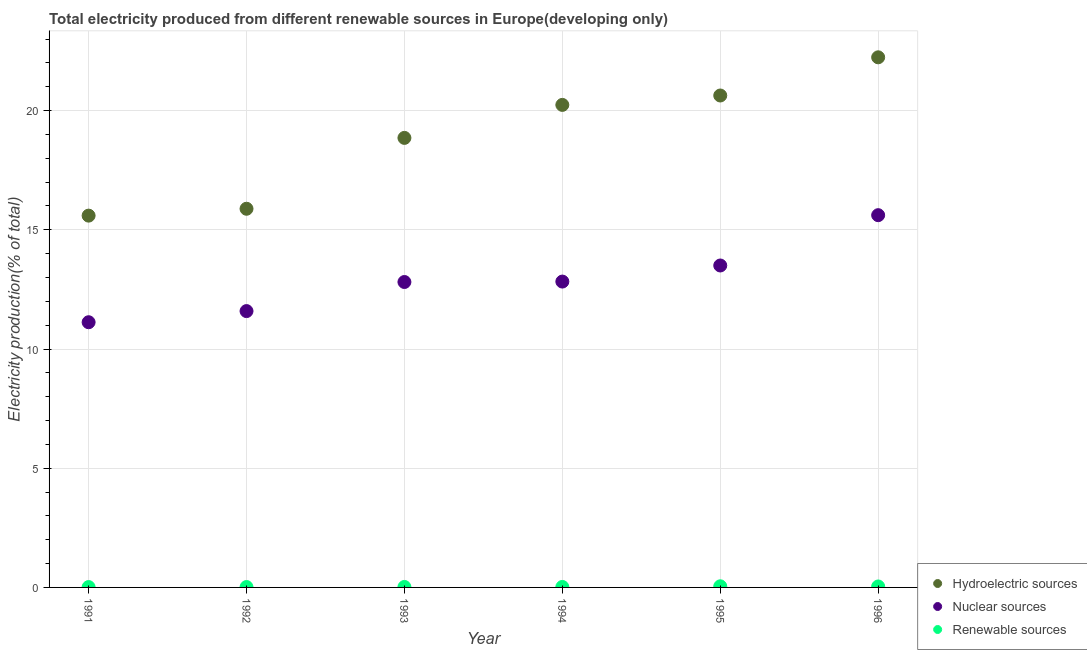How many different coloured dotlines are there?
Give a very brief answer. 3. What is the percentage of electricity produced by renewable sources in 1993?
Provide a succinct answer. 0.02. Across all years, what is the maximum percentage of electricity produced by renewable sources?
Make the answer very short. 0.05. Across all years, what is the minimum percentage of electricity produced by renewable sources?
Keep it short and to the point. 0.01. In which year was the percentage of electricity produced by renewable sources maximum?
Offer a terse response. 1995. In which year was the percentage of electricity produced by hydroelectric sources minimum?
Make the answer very short. 1991. What is the total percentage of electricity produced by renewable sources in the graph?
Offer a terse response. 0.16. What is the difference between the percentage of electricity produced by renewable sources in 1993 and that in 1994?
Make the answer very short. -0. What is the difference between the percentage of electricity produced by nuclear sources in 1995 and the percentage of electricity produced by hydroelectric sources in 1992?
Provide a short and direct response. -2.38. What is the average percentage of electricity produced by hydroelectric sources per year?
Ensure brevity in your answer.  18.91. In the year 1992, what is the difference between the percentage of electricity produced by nuclear sources and percentage of electricity produced by renewable sources?
Provide a succinct answer. 11.58. In how many years, is the percentage of electricity produced by hydroelectric sources greater than 1 %?
Ensure brevity in your answer.  6. What is the ratio of the percentage of electricity produced by renewable sources in 1991 to that in 1995?
Keep it short and to the point. 0.32. What is the difference between the highest and the second highest percentage of electricity produced by renewable sources?
Keep it short and to the point. 0.01. What is the difference between the highest and the lowest percentage of electricity produced by hydroelectric sources?
Provide a short and direct response. 6.64. In how many years, is the percentage of electricity produced by renewable sources greater than the average percentage of electricity produced by renewable sources taken over all years?
Provide a succinct answer. 2. Does the percentage of electricity produced by nuclear sources monotonically increase over the years?
Offer a very short reply. Yes. Does the graph contain any zero values?
Your answer should be compact. No. How are the legend labels stacked?
Offer a terse response. Vertical. What is the title of the graph?
Offer a terse response. Total electricity produced from different renewable sources in Europe(developing only). Does "Social Protection and Labor" appear as one of the legend labels in the graph?
Your answer should be very brief. No. What is the Electricity production(% of total) of Hydroelectric sources in 1991?
Offer a very short reply. 15.6. What is the Electricity production(% of total) of Nuclear sources in 1991?
Provide a succinct answer. 11.12. What is the Electricity production(% of total) in Renewable sources in 1991?
Ensure brevity in your answer.  0.01. What is the Electricity production(% of total) of Hydroelectric sources in 1992?
Give a very brief answer. 15.88. What is the Electricity production(% of total) of Nuclear sources in 1992?
Give a very brief answer. 11.59. What is the Electricity production(% of total) in Renewable sources in 1992?
Your response must be concise. 0.02. What is the Electricity production(% of total) of Hydroelectric sources in 1993?
Provide a succinct answer. 18.86. What is the Electricity production(% of total) in Nuclear sources in 1993?
Keep it short and to the point. 12.81. What is the Electricity production(% of total) of Renewable sources in 1993?
Give a very brief answer. 0.02. What is the Electricity production(% of total) in Hydroelectric sources in 1994?
Provide a short and direct response. 20.24. What is the Electricity production(% of total) of Nuclear sources in 1994?
Make the answer very short. 12.83. What is the Electricity production(% of total) of Renewable sources in 1994?
Your response must be concise. 0.02. What is the Electricity production(% of total) in Hydroelectric sources in 1995?
Provide a short and direct response. 20.63. What is the Electricity production(% of total) in Nuclear sources in 1995?
Give a very brief answer. 13.5. What is the Electricity production(% of total) in Renewable sources in 1995?
Ensure brevity in your answer.  0.05. What is the Electricity production(% of total) in Hydroelectric sources in 1996?
Give a very brief answer. 22.24. What is the Electricity production(% of total) in Nuclear sources in 1996?
Give a very brief answer. 15.61. What is the Electricity production(% of total) of Renewable sources in 1996?
Offer a terse response. 0.04. Across all years, what is the maximum Electricity production(% of total) of Hydroelectric sources?
Provide a succinct answer. 22.24. Across all years, what is the maximum Electricity production(% of total) of Nuclear sources?
Offer a terse response. 15.61. Across all years, what is the maximum Electricity production(% of total) in Renewable sources?
Give a very brief answer. 0.05. Across all years, what is the minimum Electricity production(% of total) in Hydroelectric sources?
Provide a succinct answer. 15.6. Across all years, what is the minimum Electricity production(% of total) in Nuclear sources?
Give a very brief answer. 11.12. Across all years, what is the minimum Electricity production(% of total) in Renewable sources?
Provide a succinct answer. 0.01. What is the total Electricity production(% of total) of Hydroelectric sources in the graph?
Give a very brief answer. 113.45. What is the total Electricity production(% of total) of Nuclear sources in the graph?
Provide a succinct answer. 77.48. What is the total Electricity production(% of total) in Renewable sources in the graph?
Keep it short and to the point. 0.16. What is the difference between the Electricity production(% of total) in Hydroelectric sources in 1991 and that in 1992?
Your response must be concise. -0.29. What is the difference between the Electricity production(% of total) of Nuclear sources in 1991 and that in 1992?
Your answer should be very brief. -0.47. What is the difference between the Electricity production(% of total) of Renewable sources in 1991 and that in 1992?
Your answer should be very brief. -0. What is the difference between the Electricity production(% of total) of Hydroelectric sources in 1991 and that in 1993?
Your response must be concise. -3.26. What is the difference between the Electricity production(% of total) in Nuclear sources in 1991 and that in 1993?
Give a very brief answer. -1.69. What is the difference between the Electricity production(% of total) in Renewable sources in 1991 and that in 1993?
Your answer should be compact. -0. What is the difference between the Electricity production(% of total) in Hydroelectric sources in 1991 and that in 1994?
Your answer should be compact. -4.64. What is the difference between the Electricity production(% of total) in Nuclear sources in 1991 and that in 1994?
Your answer should be very brief. -1.71. What is the difference between the Electricity production(% of total) in Renewable sources in 1991 and that in 1994?
Provide a succinct answer. -0. What is the difference between the Electricity production(% of total) in Hydroelectric sources in 1991 and that in 1995?
Provide a short and direct response. -5.04. What is the difference between the Electricity production(% of total) of Nuclear sources in 1991 and that in 1995?
Keep it short and to the point. -2.38. What is the difference between the Electricity production(% of total) in Renewable sources in 1991 and that in 1995?
Offer a very short reply. -0.03. What is the difference between the Electricity production(% of total) of Hydroelectric sources in 1991 and that in 1996?
Your response must be concise. -6.64. What is the difference between the Electricity production(% of total) of Nuclear sources in 1991 and that in 1996?
Offer a terse response. -4.49. What is the difference between the Electricity production(% of total) in Renewable sources in 1991 and that in 1996?
Offer a very short reply. -0.03. What is the difference between the Electricity production(% of total) in Hydroelectric sources in 1992 and that in 1993?
Offer a terse response. -2.97. What is the difference between the Electricity production(% of total) of Nuclear sources in 1992 and that in 1993?
Make the answer very short. -1.22. What is the difference between the Electricity production(% of total) of Renewable sources in 1992 and that in 1993?
Offer a very short reply. -0. What is the difference between the Electricity production(% of total) of Hydroelectric sources in 1992 and that in 1994?
Ensure brevity in your answer.  -4.36. What is the difference between the Electricity production(% of total) of Nuclear sources in 1992 and that in 1994?
Keep it short and to the point. -1.24. What is the difference between the Electricity production(% of total) of Renewable sources in 1992 and that in 1994?
Make the answer very short. -0. What is the difference between the Electricity production(% of total) in Hydroelectric sources in 1992 and that in 1995?
Your answer should be very brief. -4.75. What is the difference between the Electricity production(% of total) in Nuclear sources in 1992 and that in 1995?
Provide a short and direct response. -1.91. What is the difference between the Electricity production(% of total) of Renewable sources in 1992 and that in 1995?
Your answer should be very brief. -0.03. What is the difference between the Electricity production(% of total) of Hydroelectric sources in 1992 and that in 1996?
Provide a succinct answer. -6.35. What is the difference between the Electricity production(% of total) in Nuclear sources in 1992 and that in 1996?
Ensure brevity in your answer.  -4.02. What is the difference between the Electricity production(% of total) in Renewable sources in 1992 and that in 1996?
Your response must be concise. -0.02. What is the difference between the Electricity production(% of total) of Hydroelectric sources in 1993 and that in 1994?
Give a very brief answer. -1.38. What is the difference between the Electricity production(% of total) of Nuclear sources in 1993 and that in 1994?
Provide a succinct answer. -0.02. What is the difference between the Electricity production(% of total) in Renewable sources in 1993 and that in 1994?
Offer a terse response. -0. What is the difference between the Electricity production(% of total) in Hydroelectric sources in 1993 and that in 1995?
Ensure brevity in your answer.  -1.78. What is the difference between the Electricity production(% of total) of Nuclear sources in 1993 and that in 1995?
Offer a terse response. -0.69. What is the difference between the Electricity production(% of total) in Renewable sources in 1993 and that in 1995?
Your answer should be compact. -0.03. What is the difference between the Electricity production(% of total) in Hydroelectric sources in 1993 and that in 1996?
Keep it short and to the point. -3.38. What is the difference between the Electricity production(% of total) in Nuclear sources in 1993 and that in 1996?
Provide a succinct answer. -2.8. What is the difference between the Electricity production(% of total) in Renewable sources in 1993 and that in 1996?
Your answer should be compact. -0.02. What is the difference between the Electricity production(% of total) of Hydroelectric sources in 1994 and that in 1995?
Offer a very short reply. -0.39. What is the difference between the Electricity production(% of total) in Nuclear sources in 1994 and that in 1995?
Ensure brevity in your answer.  -0.67. What is the difference between the Electricity production(% of total) in Renewable sources in 1994 and that in 1995?
Give a very brief answer. -0.03. What is the difference between the Electricity production(% of total) in Hydroelectric sources in 1994 and that in 1996?
Your answer should be compact. -2. What is the difference between the Electricity production(% of total) in Nuclear sources in 1994 and that in 1996?
Provide a succinct answer. -2.79. What is the difference between the Electricity production(% of total) in Renewable sources in 1994 and that in 1996?
Ensure brevity in your answer.  -0.02. What is the difference between the Electricity production(% of total) in Hydroelectric sources in 1995 and that in 1996?
Your answer should be compact. -1.6. What is the difference between the Electricity production(% of total) in Nuclear sources in 1995 and that in 1996?
Your answer should be very brief. -2.11. What is the difference between the Electricity production(% of total) of Renewable sources in 1995 and that in 1996?
Offer a very short reply. 0.01. What is the difference between the Electricity production(% of total) of Hydroelectric sources in 1991 and the Electricity production(% of total) of Nuclear sources in 1992?
Offer a terse response. 4. What is the difference between the Electricity production(% of total) in Hydroelectric sources in 1991 and the Electricity production(% of total) in Renewable sources in 1992?
Your response must be concise. 15.58. What is the difference between the Electricity production(% of total) in Nuclear sources in 1991 and the Electricity production(% of total) in Renewable sources in 1992?
Ensure brevity in your answer.  11.11. What is the difference between the Electricity production(% of total) of Hydroelectric sources in 1991 and the Electricity production(% of total) of Nuclear sources in 1993?
Your response must be concise. 2.78. What is the difference between the Electricity production(% of total) of Hydroelectric sources in 1991 and the Electricity production(% of total) of Renewable sources in 1993?
Keep it short and to the point. 15.58. What is the difference between the Electricity production(% of total) in Nuclear sources in 1991 and the Electricity production(% of total) in Renewable sources in 1993?
Give a very brief answer. 11.1. What is the difference between the Electricity production(% of total) of Hydroelectric sources in 1991 and the Electricity production(% of total) of Nuclear sources in 1994?
Provide a succinct answer. 2.77. What is the difference between the Electricity production(% of total) in Hydroelectric sources in 1991 and the Electricity production(% of total) in Renewable sources in 1994?
Your answer should be compact. 15.58. What is the difference between the Electricity production(% of total) of Nuclear sources in 1991 and the Electricity production(% of total) of Renewable sources in 1994?
Your answer should be compact. 11.1. What is the difference between the Electricity production(% of total) of Hydroelectric sources in 1991 and the Electricity production(% of total) of Nuclear sources in 1995?
Your answer should be compact. 2.09. What is the difference between the Electricity production(% of total) of Hydroelectric sources in 1991 and the Electricity production(% of total) of Renewable sources in 1995?
Your response must be concise. 15.55. What is the difference between the Electricity production(% of total) in Nuclear sources in 1991 and the Electricity production(% of total) in Renewable sources in 1995?
Offer a terse response. 11.08. What is the difference between the Electricity production(% of total) in Hydroelectric sources in 1991 and the Electricity production(% of total) in Nuclear sources in 1996?
Your answer should be very brief. -0.02. What is the difference between the Electricity production(% of total) in Hydroelectric sources in 1991 and the Electricity production(% of total) in Renewable sources in 1996?
Your response must be concise. 15.56. What is the difference between the Electricity production(% of total) in Nuclear sources in 1991 and the Electricity production(% of total) in Renewable sources in 1996?
Give a very brief answer. 11.08. What is the difference between the Electricity production(% of total) in Hydroelectric sources in 1992 and the Electricity production(% of total) in Nuclear sources in 1993?
Provide a succinct answer. 3.07. What is the difference between the Electricity production(% of total) in Hydroelectric sources in 1992 and the Electricity production(% of total) in Renewable sources in 1993?
Your answer should be very brief. 15.86. What is the difference between the Electricity production(% of total) of Nuclear sources in 1992 and the Electricity production(% of total) of Renewable sources in 1993?
Ensure brevity in your answer.  11.57. What is the difference between the Electricity production(% of total) in Hydroelectric sources in 1992 and the Electricity production(% of total) in Nuclear sources in 1994?
Offer a very short reply. 3.05. What is the difference between the Electricity production(% of total) in Hydroelectric sources in 1992 and the Electricity production(% of total) in Renewable sources in 1994?
Provide a short and direct response. 15.86. What is the difference between the Electricity production(% of total) of Nuclear sources in 1992 and the Electricity production(% of total) of Renewable sources in 1994?
Make the answer very short. 11.57. What is the difference between the Electricity production(% of total) in Hydroelectric sources in 1992 and the Electricity production(% of total) in Nuclear sources in 1995?
Your answer should be very brief. 2.38. What is the difference between the Electricity production(% of total) of Hydroelectric sources in 1992 and the Electricity production(% of total) of Renewable sources in 1995?
Make the answer very short. 15.84. What is the difference between the Electricity production(% of total) of Nuclear sources in 1992 and the Electricity production(% of total) of Renewable sources in 1995?
Provide a succinct answer. 11.54. What is the difference between the Electricity production(% of total) in Hydroelectric sources in 1992 and the Electricity production(% of total) in Nuclear sources in 1996?
Give a very brief answer. 0.27. What is the difference between the Electricity production(% of total) in Hydroelectric sources in 1992 and the Electricity production(% of total) in Renewable sources in 1996?
Make the answer very short. 15.84. What is the difference between the Electricity production(% of total) in Nuclear sources in 1992 and the Electricity production(% of total) in Renewable sources in 1996?
Your answer should be very brief. 11.55. What is the difference between the Electricity production(% of total) of Hydroelectric sources in 1993 and the Electricity production(% of total) of Nuclear sources in 1994?
Offer a very short reply. 6.03. What is the difference between the Electricity production(% of total) of Hydroelectric sources in 1993 and the Electricity production(% of total) of Renewable sources in 1994?
Offer a very short reply. 18.84. What is the difference between the Electricity production(% of total) in Nuclear sources in 1993 and the Electricity production(% of total) in Renewable sources in 1994?
Your answer should be compact. 12.79. What is the difference between the Electricity production(% of total) of Hydroelectric sources in 1993 and the Electricity production(% of total) of Nuclear sources in 1995?
Your answer should be compact. 5.35. What is the difference between the Electricity production(% of total) of Hydroelectric sources in 1993 and the Electricity production(% of total) of Renewable sources in 1995?
Provide a succinct answer. 18.81. What is the difference between the Electricity production(% of total) of Nuclear sources in 1993 and the Electricity production(% of total) of Renewable sources in 1995?
Offer a very short reply. 12.76. What is the difference between the Electricity production(% of total) of Hydroelectric sources in 1993 and the Electricity production(% of total) of Nuclear sources in 1996?
Your answer should be very brief. 3.24. What is the difference between the Electricity production(% of total) in Hydroelectric sources in 1993 and the Electricity production(% of total) in Renewable sources in 1996?
Offer a very short reply. 18.82. What is the difference between the Electricity production(% of total) in Nuclear sources in 1993 and the Electricity production(% of total) in Renewable sources in 1996?
Keep it short and to the point. 12.77. What is the difference between the Electricity production(% of total) of Hydroelectric sources in 1994 and the Electricity production(% of total) of Nuclear sources in 1995?
Offer a very short reply. 6.74. What is the difference between the Electricity production(% of total) of Hydroelectric sources in 1994 and the Electricity production(% of total) of Renewable sources in 1995?
Ensure brevity in your answer.  20.19. What is the difference between the Electricity production(% of total) in Nuclear sources in 1994 and the Electricity production(% of total) in Renewable sources in 1995?
Ensure brevity in your answer.  12.78. What is the difference between the Electricity production(% of total) of Hydroelectric sources in 1994 and the Electricity production(% of total) of Nuclear sources in 1996?
Make the answer very short. 4.63. What is the difference between the Electricity production(% of total) in Hydroelectric sources in 1994 and the Electricity production(% of total) in Renewable sources in 1996?
Ensure brevity in your answer.  20.2. What is the difference between the Electricity production(% of total) of Nuclear sources in 1994 and the Electricity production(% of total) of Renewable sources in 1996?
Your answer should be very brief. 12.79. What is the difference between the Electricity production(% of total) in Hydroelectric sources in 1995 and the Electricity production(% of total) in Nuclear sources in 1996?
Keep it short and to the point. 5.02. What is the difference between the Electricity production(% of total) in Hydroelectric sources in 1995 and the Electricity production(% of total) in Renewable sources in 1996?
Your answer should be very brief. 20.59. What is the difference between the Electricity production(% of total) in Nuclear sources in 1995 and the Electricity production(% of total) in Renewable sources in 1996?
Your answer should be very brief. 13.46. What is the average Electricity production(% of total) in Hydroelectric sources per year?
Provide a short and direct response. 18.91. What is the average Electricity production(% of total) in Nuclear sources per year?
Your answer should be very brief. 12.91. What is the average Electricity production(% of total) of Renewable sources per year?
Your answer should be compact. 0.03. In the year 1991, what is the difference between the Electricity production(% of total) of Hydroelectric sources and Electricity production(% of total) of Nuclear sources?
Offer a very short reply. 4.47. In the year 1991, what is the difference between the Electricity production(% of total) of Hydroelectric sources and Electricity production(% of total) of Renewable sources?
Your answer should be compact. 15.58. In the year 1991, what is the difference between the Electricity production(% of total) in Nuclear sources and Electricity production(% of total) in Renewable sources?
Offer a very short reply. 11.11. In the year 1992, what is the difference between the Electricity production(% of total) in Hydroelectric sources and Electricity production(% of total) in Nuclear sources?
Make the answer very short. 4.29. In the year 1992, what is the difference between the Electricity production(% of total) in Hydroelectric sources and Electricity production(% of total) in Renewable sources?
Offer a very short reply. 15.87. In the year 1992, what is the difference between the Electricity production(% of total) in Nuclear sources and Electricity production(% of total) in Renewable sources?
Make the answer very short. 11.58. In the year 1993, what is the difference between the Electricity production(% of total) in Hydroelectric sources and Electricity production(% of total) in Nuclear sources?
Offer a terse response. 6.05. In the year 1993, what is the difference between the Electricity production(% of total) in Hydroelectric sources and Electricity production(% of total) in Renewable sources?
Make the answer very short. 18.84. In the year 1993, what is the difference between the Electricity production(% of total) of Nuclear sources and Electricity production(% of total) of Renewable sources?
Your response must be concise. 12.79. In the year 1994, what is the difference between the Electricity production(% of total) of Hydroelectric sources and Electricity production(% of total) of Nuclear sources?
Your response must be concise. 7.41. In the year 1994, what is the difference between the Electricity production(% of total) of Hydroelectric sources and Electricity production(% of total) of Renewable sources?
Offer a very short reply. 20.22. In the year 1994, what is the difference between the Electricity production(% of total) of Nuclear sources and Electricity production(% of total) of Renewable sources?
Provide a succinct answer. 12.81. In the year 1995, what is the difference between the Electricity production(% of total) in Hydroelectric sources and Electricity production(% of total) in Nuclear sources?
Your response must be concise. 7.13. In the year 1995, what is the difference between the Electricity production(% of total) in Hydroelectric sources and Electricity production(% of total) in Renewable sources?
Provide a succinct answer. 20.59. In the year 1995, what is the difference between the Electricity production(% of total) of Nuclear sources and Electricity production(% of total) of Renewable sources?
Make the answer very short. 13.46. In the year 1996, what is the difference between the Electricity production(% of total) of Hydroelectric sources and Electricity production(% of total) of Nuclear sources?
Offer a terse response. 6.62. In the year 1996, what is the difference between the Electricity production(% of total) in Hydroelectric sources and Electricity production(% of total) in Renewable sources?
Keep it short and to the point. 22.2. In the year 1996, what is the difference between the Electricity production(% of total) of Nuclear sources and Electricity production(% of total) of Renewable sources?
Your response must be concise. 15.57. What is the ratio of the Electricity production(% of total) of Hydroelectric sources in 1991 to that in 1992?
Your response must be concise. 0.98. What is the ratio of the Electricity production(% of total) of Nuclear sources in 1991 to that in 1992?
Ensure brevity in your answer.  0.96. What is the ratio of the Electricity production(% of total) in Renewable sources in 1991 to that in 1992?
Provide a short and direct response. 0.93. What is the ratio of the Electricity production(% of total) of Hydroelectric sources in 1991 to that in 1993?
Make the answer very short. 0.83. What is the ratio of the Electricity production(% of total) in Nuclear sources in 1991 to that in 1993?
Offer a very short reply. 0.87. What is the ratio of the Electricity production(% of total) in Renewable sources in 1991 to that in 1993?
Ensure brevity in your answer.  0.77. What is the ratio of the Electricity production(% of total) of Hydroelectric sources in 1991 to that in 1994?
Make the answer very short. 0.77. What is the ratio of the Electricity production(% of total) of Nuclear sources in 1991 to that in 1994?
Your answer should be compact. 0.87. What is the ratio of the Electricity production(% of total) in Renewable sources in 1991 to that in 1994?
Provide a succinct answer. 0.76. What is the ratio of the Electricity production(% of total) in Hydroelectric sources in 1991 to that in 1995?
Provide a short and direct response. 0.76. What is the ratio of the Electricity production(% of total) of Nuclear sources in 1991 to that in 1995?
Offer a very short reply. 0.82. What is the ratio of the Electricity production(% of total) of Renewable sources in 1991 to that in 1995?
Keep it short and to the point. 0.32. What is the ratio of the Electricity production(% of total) in Hydroelectric sources in 1991 to that in 1996?
Offer a very short reply. 0.7. What is the ratio of the Electricity production(% of total) of Nuclear sources in 1991 to that in 1996?
Your answer should be compact. 0.71. What is the ratio of the Electricity production(% of total) of Renewable sources in 1991 to that in 1996?
Your answer should be very brief. 0.37. What is the ratio of the Electricity production(% of total) of Hydroelectric sources in 1992 to that in 1993?
Ensure brevity in your answer.  0.84. What is the ratio of the Electricity production(% of total) of Nuclear sources in 1992 to that in 1993?
Your answer should be compact. 0.9. What is the ratio of the Electricity production(% of total) in Renewable sources in 1992 to that in 1993?
Your answer should be very brief. 0.83. What is the ratio of the Electricity production(% of total) of Hydroelectric sources in 1992 to that in 1994?
Offer a very short reply. 0.78. What is the ratio of the Electricity production(% of total) in Nuclear sources in 1992 to that in 1994?
Your response must be concise. 0.9. What is the ratio of the Electricity production(% of total) in Renewable sources in 1992 to that in 1994?
Provide a short and direct response. 0.82. What is the ratio of the Electricity production(% of total) in Hydroelectric sources in 1992 to that in 1995?
Keep it short and to the point. 0.77. What is the ratio of the Electricity production(% of total) of Nuclear sources in 1992 to that in 1995?
Offer a terse response. 0.86. What is the ratio of the Electricity production(% of total) in Renewable sources in 1992 to that in 1995?
Your response must be concise. 0.34. What is the ratio of the Electricity production(% of total) of Hydroelectric sources in 1992 to that in 1996?
Offer a very short reply. 0.71. What is the ratio of the Electricity production(% of total) in Nuclear sources in 1992 to that in 1996?
Provide a succinct answer. 0.74. What is the ratio of the Electricity production(% of total) in Renewable sources in 1992 to that in 1996?
Offer a terse response. 0.4. What is the ratio of the Electricity production(% of total) of Hydroelectric sources in 1993 to that in 1994?
Offer a terse response. 0.93. What is the ratio of the Electricity production(% of total) of Nuclear sources in 1993 to that in 1994?
Your answer should be compact. 1. What is the ratio of the Electricity production(% of total) of Renewable sources in 1993 to that in 1994?
Give a very brief answer. 0.98. What is the ratio of the Electricity production(% of total) of Hydroelectric sources in 1993 to that in 1995?
Provide a succinct answer. 0.91. What is the ratio of the Electricity production(% of total) of Nuclear sources in 1993 to that in 1995?
Provide a succinct answer. 0.95. What is the ratio of the Electricity production(% of total) in Renewable sources in 1993 to that in 1995?
Ensure brevity in your answer.  0.41. What is the ratio of the Electricity production(% of total) of Hydroelectric sources in 1993 to that in 1996?
Provide a succinct answer. 0.85. What is the ratio of the Electricity production(% of total) of Nuclear sources in 1993 to that in 1996?
Make the answer very short. 0.82. What is the ratio of the Electricity production(% of total) of Renewable sources in 1993 to that in 1996?
Make the answer very short. 0.48. What is the ratio of the Electricity production(% of total) in Hydroelectric sources in 1994 to that in 1995?
Keep it short and to the point. 0.98. What is the ratio of the Electricity production(% of total) of Nuclear sources in 1994 to that in 1995?
Your answer should be compact. 0.95. What is the ratio of the Electricity production(% of total) of Renewable sources in 1994 to that in 1995?
Offer a terse response. 0.42. What is the ratio of the Electricity production(% of total) of Hydroelectric sources in 1994 to that in 1996?
Your answer should be compact. 0.91. What is the ratio of the Electricity production(% of total) in Nuclear sources in 1994 to that in 1996?
Give a very brief answer. 0.82. What is the ratio of the Electricity production(% of total) of Renewable sources in 1994 to that in 1996?
Offer a very short reply. 0.49. What is the ratio of the Electricity production(% of total) in Hydroelectric sources in 1995 to that in 1996?
Offer a very short reply. 0.93. What is the ratio of the Electricity production(% of total) in Nuclear sources in 1995 to that in 1996?
Offer a terse response. 0.86. What is the ratio of the Electricity production(% of total) of Renewable sources in 1995 to that in 1996?
Give a very brief answer. 1.18. What is the difference between the highest and the second highest Electricity production(% of total) in Hydroelectric sources?
Ensure brevity in your answer.  1.6. What is the difference between the highest and the second highest Electricity production(% of total) in Nuclear sources?
Provide a succinct answer. 2.11. What is the difference between the highest and the second highest Electricity production(% of total) in Renewable sources?
Your answer should be very brief. 0.01. What is the difference between the highest and the lowest Electricity production(% of total) in Hydroelectric sources?
Give a very brief answer. 6.64. What is the difference between the highest and the lowest Electricity production(% of total) of Nuclear sources?
Offer a terse response. 4.49. What is the difference between the highest and the lowest Electricity production(% of total) in Renewable sources?
Your answer should be very brief. 0.03. 